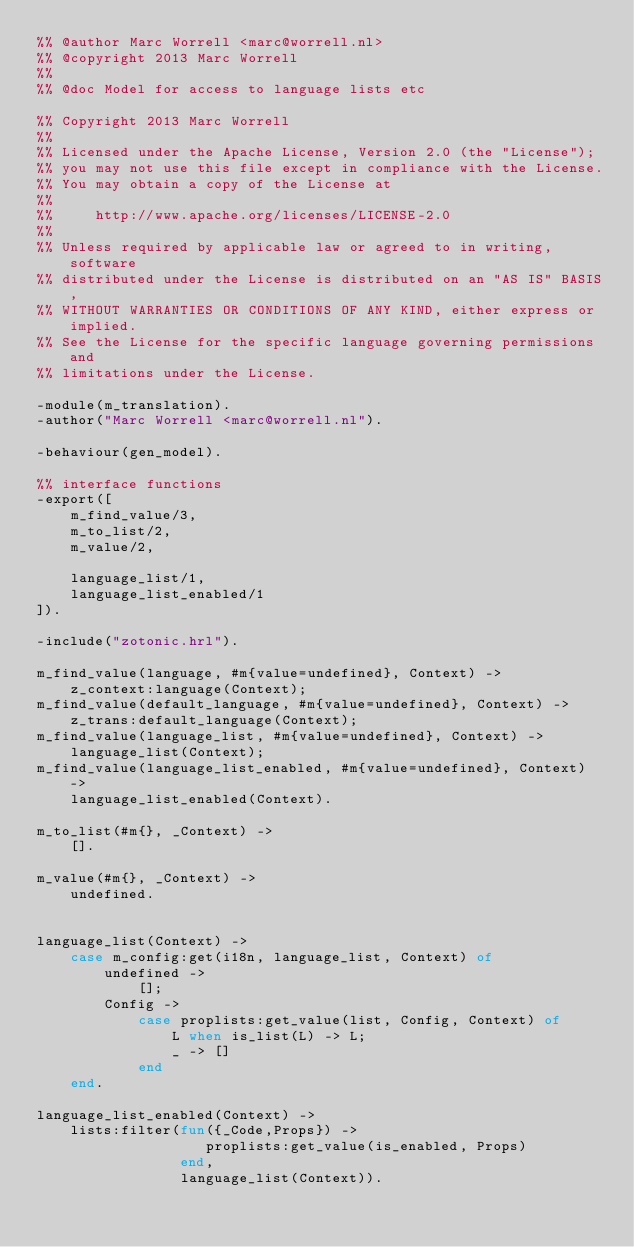Convert code to text. <code><loc_0><loc_0><loc_500><loc_500><_Erlang_>%% @author Marc Worrell <marc@worrell.nl>
%% @copyright 2013 Marc Worrell
%%
%% @doc Model for access to language lists etc

%% Copyright 2013 Marc Worrell
%%
%% Licensed under the Apache License, Version 2.0 (the "License");
%% you may not use this file except in compliance with the License.
%% You may obtain a copy of the License at
%% 
%%     http://www.apache.org/licenses/LICENSE-2.0
%% 
%% Unless required by applicable law or agreed to in writing, software
%% distributed under the License is distributed on an "AS IS" BASIS,
%% WITHOUT WARRANTIES OR CONDITIONS OF ANY KIND, either express or implied.
%% See the License for the specific language governing permissions and
%% limitations under the License.

-module(m_translation).
-author("Marc Worrell <marc@worrell.nl").

-behaviour(gen_model).

%% interface functions
-export([
    m_find_value/3,
    m_to_list/2,
    m_value/2,

    language_list/1,
    language_list_enabled/1
]).

-include("zotonic.hrl").

m_find_value(language, #m{value=undefined}, Context) ->
	z_context:language(Context);
m_find_value(default_language, #m{value=undefined}, Context) ->
	z_trans:default_language(Context);
m_find_value(language_list, #m{value=undefined}, Context) ->
	language_list(Context);
m_find_value(language_list_enabled, #m{value=undefined}, Context) ->
	language_list_enabled(Context).

m_to_list(#m{}, _Context) ->
	[].

m_value(#m{}, _Context) ->
	undefined.


language_list(Context) ->
	case m_config:get(i18n, language_list, Context) of
		undefined -> 
			[];
		Config ->
			case proplists:get_value(list, Config, Context) of
				L when is_list(L) -> L;
				_ -> []
			end
	end.

language_list_enabled(Context) ->
	lists:filter(fun({_Code,Props}) ->
					proplists:get_value(is_enabled, Props)
				 end,
				 language_list(Context)).
</code> 